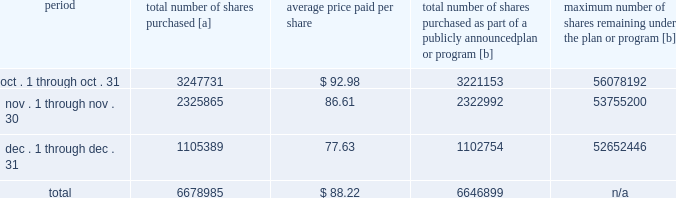Five-year performance comparison 2013 the following graph provides an indicator of cumulative total shareholder returns for the corporation as compared to the peer group index ( described above ) , the dj trans , and the s&p 500 .
The graph assumes that $ 100 was invested in the common stock of union pacific corporation and each index on december 31 , 2010 and that all dividends were reinvested .
The information below is historical in nature and is not necessarily indicative of future performance .
Purchases of equity securities 2013 during 2015 , we repurchased 36921641 shares of our common stock at an average price of $ 99.16 .
The table presents common stock repurchases during each month for the fourth quarter of 2015 : period total number of shares purchased [a] average price paid per share total number of shares purchased as part of a publicly announced plan or program [b] maximum number of shares remaining under the plan or program [b] .
[a] total number of shares purchased during the quarter includes approximately 32086 shares delivered or attested to upc by employees to pay stock option exercise prices , satisfy excess tax withholding obligations for stock option exercises or vesting of retention units , and pay withholding obligations for vesting of retention shares .
[b] effective january 1 , 2014 , our board of directors authorized the repurchase of up to 120 million shares of our common stock by december 31 , 2017 .
These repurchases may be made on the open market or through other transactions .
Our management has sole discretion with respect to determining the timing and amount of these transactions. .
What percentage of total shares purchased were purchased in november? 
Computations: (2325865 / 6678985)
Answer: 0.34824. 